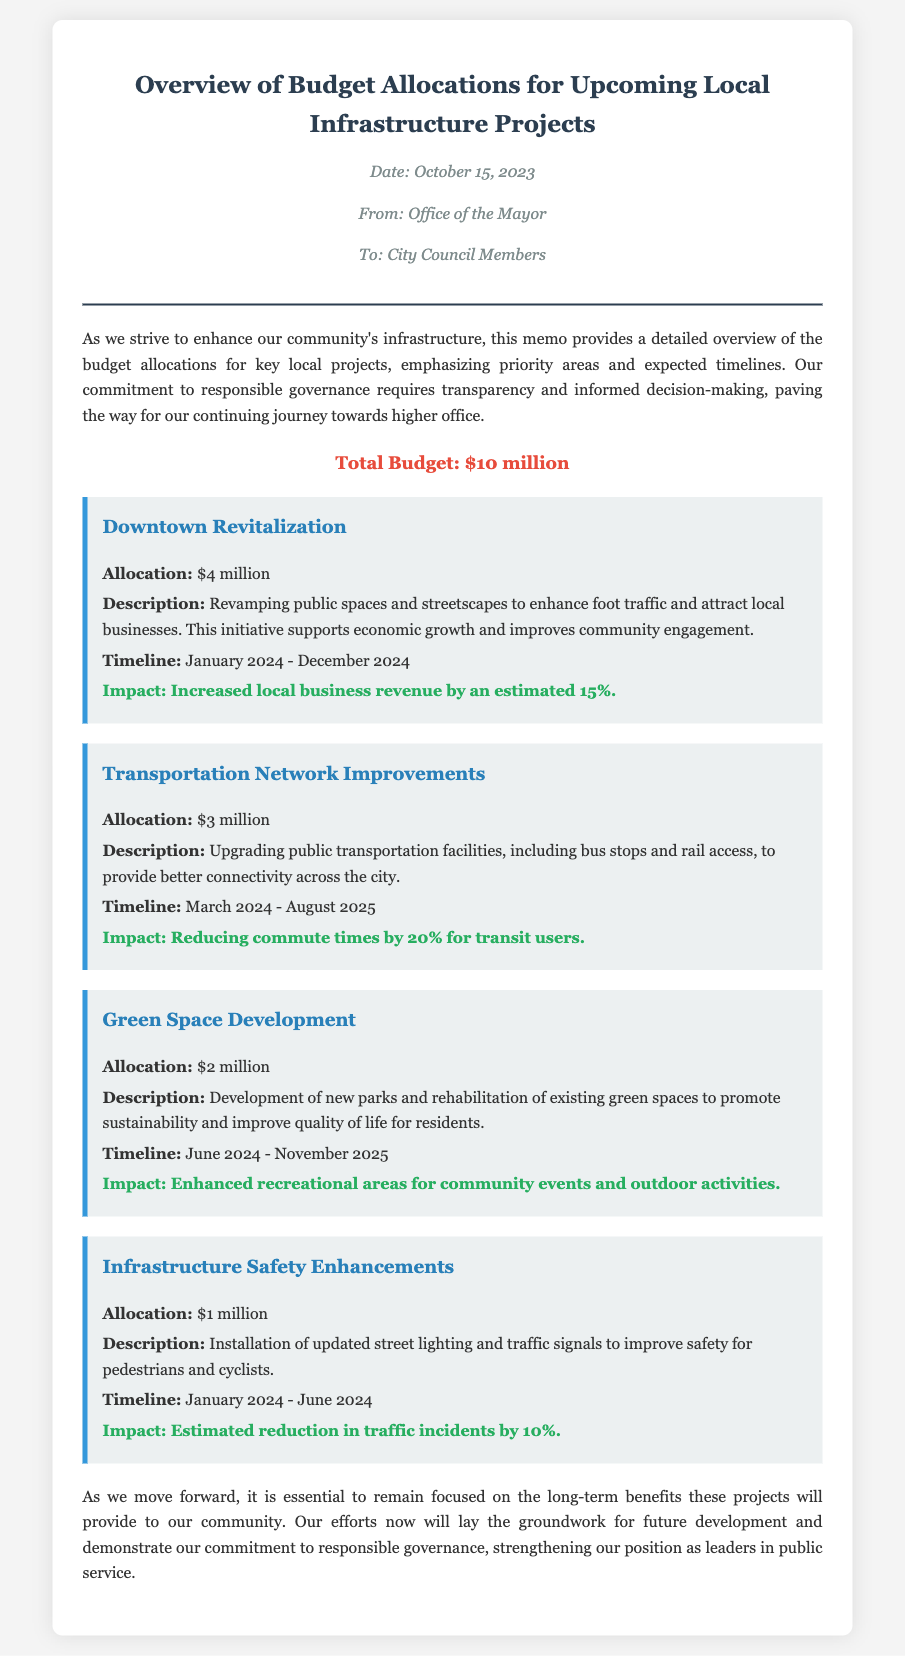What is the total budget? The total budget is stated clearly in the document as the sum allocated for all projects.
Answer: $10 million What is the allocation for Downtown Revitalization? The allocation for the Downtown Revitalization project is provided in the project details section.
Answer: $4 million What is the timeline for Transportation Network Improvements? The timeline for this project is indicated in its description.
Answer: March 2024 - August 2025 What is the expected impact of the Green Space Development? The document outlines the anticipated impact of the Green Space Development project.
Answer: Enhanced recreational areas for community events and outdoor activities Which project has the smallest budget allocation? The question looks for the project with the lowest budget allocation mentioned in the document.
Answer: Infrastructure Safety Enhancements How much budget is allocated to Infrastructure Safety Enhancements? This detail is provided under the specific project section in the memo.
Answer: $1 million What is the impact of the Downtown Revitalization project? The expected impact is described in the project overview.
Answer: Increased local business revenue by an estimated 15% Who is the memo addressed to? The recipients of the memo are stated at the beginning of the document.
Answer: City Council Members 